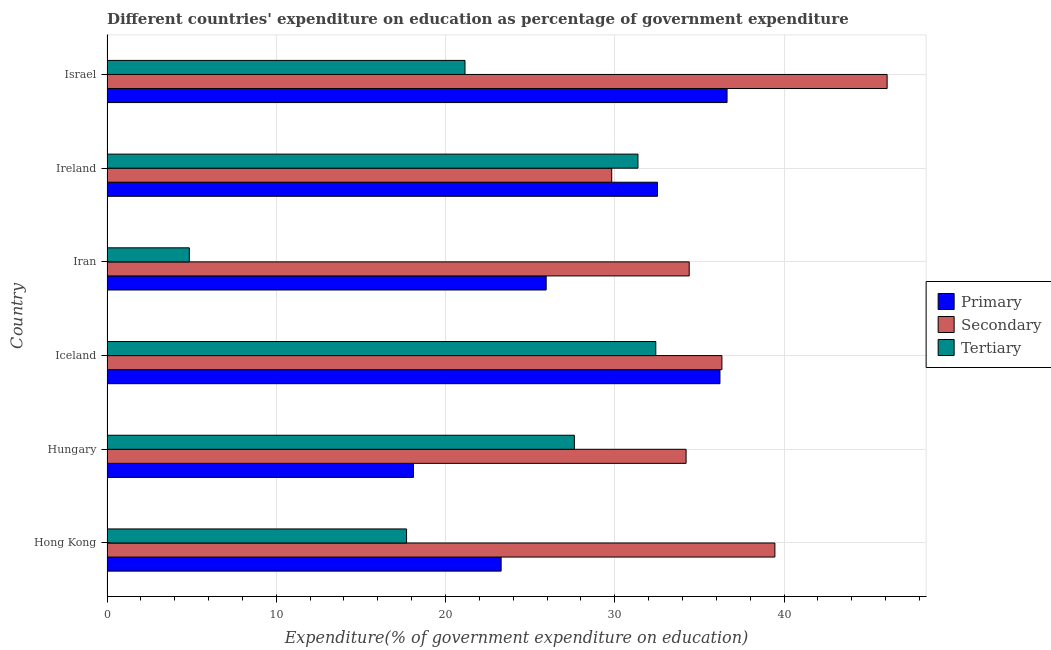How many groups of bars are there?
Your answer should be very brief. 6. How many bars are there on the 4th tick from the top?
Your answer should be compact. 3. What is the label of the 5th group of bars from the top?
Offer a very short reply. Hungary. In how many cases, is the number of bars for a given country not equal to the number of legend labels?
Give a very brief answer. 0. What is the expenditure on secondary education in Israel?
Provide a short and direct response. 46.09. Across all countries, what is the maximum expenditure on tertiary education?
Your response must be concise. 32.42. Across all countries, what is the minimum expenditure on secondary education?
Give a very brief answer. 29.82. In which country was the expenditure on primary education maximum?
Ensure brevity in your answer.  Israel. In which country was the expenditure on secondary education minimum?
Give a very brief answer. Ireland. What is the total expenditure on primary education in the graph?
Provide a short and direct response. 172.71. What is the difference between the expenditure on primary education in Iceland and that in Iran?
Ensure brevity in your answer.  10.27. What is the difference between the expenditure on secondary education in Ireland and the expenditure on primary education in Iceland?
Provide a short and direct response. -6.4. What is the average expenditure on tertiary education per country?
Your answer should be compact. 22.52. What is the difference between the expenditure on secondary education and expenditure on primary education in Israel?
Provide a short and direct response. 9.46. In how many countries, is the expenditure on tertiary education greater than 30 %?
Make the answer very short. 2. What is the ratio of the expenditure on tertiary education in Iran to that in Ireland?
Provide a short and direct response. 0.15. Is the expenditure on primary education in Hong Kong less than that in Hungary?
Your answer should be compact. No. What is the difference between the highest and the second highest expenditure on primary education?
Give a very brief answer. 0.42. What is the difference between the highest and the lowest expenditure on secondary education?
Your answer should be very brief. 16.27. What does the 2nd bar from the top in Iceland represents?
Keep it short and to the point. Secondary. What does the 3rd bar from the bottom in Hong Kong represents?
Make the answer very short. Tertiary. Are all the bars in the graph horizontal?
Offer a very short reply. Yes. What is the difference between two consecutive major ticks on the X-axis?
Your answer should be very brief. 10. Are the values on the major ticks of X-axis written in scientific E-notation?
Your answer should be compact. No. How many legend labels are there?
Offer a terse response. 3. How are the legend labels stacked?
Offer a very short reply. Vertical. What is the title of the graph?
Keep it short and to the point. Different countries' expenditure on education as percentage of government expenditure. What is the label or title of the X-axis?
Make the answer very short. Expenditure(% of government expenditure on education). What is the Expenditure(% of government expenditure on education) of Primary in Hong Kong?
Offer a very short reply. 23.29. What is the Expenditure(% of government expenditure on education) in Secondary in Hong Kong?
Your answer should be compact. 39.46. What is the Expenditure(% of government expenditure on education) in Tertiary in Hong Kong?
Your answer should be very brief. 17.7. What is the Expenditure(% of government expenditure on education) of Primary in Hungary?
Provide a short and direct response. 18.11. What is the Expenditure(% of government expenditure on education) in Secondary in Hungary?
Provide a succinct answer. 34.21. What is the Expenditure(% of government expenditure on education) in Tertiary in Hungary?
Offer a very short reply. 27.61. What is the Expenditure(% of government expenditure on education) of Primary in Iceland?
Offer a terse response. 36.21. What is the Expenditure(% of government expenditure on education) in Secondary in Iceland?
Your answer should be very brief. 36.33. What is the Expenditure(% of government expenditure on education) of Tertiary in Iceland?
Your answer should be compact. 32.42. What is the Expenditure(% of government expenditure on education) of Primary in Iran?
Your response must be concise. 25.95. What is the Expenditure(% of government expenditure on education) in Secondary in Iran?
Make the answer very short. 34.4. What is the Expenditure(% of government expenditure on education) in Tertiary in Iran?
Your response must be concise. 4.86. What is the Expenditure(% of government expenditure on education) in Primary in Ireland?
Provide a short and direct response. 32.52. What is the Expenditure(% of government expenditure on education) in Secondary in Ireland?
Offer a terse response. 29.82. What is the Expenditure(% of government expenditure on education) of Tertiary in Ireland?
Your response must be concise. 31.37. What is the Expenditure(% of government expenditure on education) of Primary in Israel?
Provide a short and direct response. 36.63. What is the Expenditure(% of government expenditure on education) in Secondary in Israel?
Offer a very short reply. 46.09. What is the Expenditure(% of government expenditure on education) in Tertiary in Israel?
Offer a terse response. 21.15. Across all countries, what is the maximum Expenditure(% of government expenditure on education) of Primary?
Provide a succinct answer. 36.63. Across all countries, what is the maximum Expenditure(% of government expenditure on education) in Secondary?
Give a very brief answer. 46.09. Across all countries, what is the maximum Expenditure(% of government expenditure on education) of Tertiary?
Ensure brevity in your answer.  32.42. Across all countries, what is the minimum Expenditure(% of government expenditure on education) of Primary?
Provide a succinct answer. 18.11. Across all countries, what is the minimum Expenditure(% of government expenditure on education) of Secondary?
Your response must be concise. 29.82. Across all countries, what is the minimum Expenditure(% of government expenditure on education) of Tertiary?
Make the answer very short. 4.86. What is the total Expenditure(% of government expenditure on education) in Primary in the graph?
Make the answer very short. 172.71. What is the total Expenditure(% of government expenditure on education) in Secondary in the graph?
Offer a terse response. 220.31. What is the total Expenditure(% of government expenditure on education) of Tertiary in the graph?
Make the answer very short. 135.12. What is the difference between the Expenditure(% of government expenditure on education) of Primary in Hong Kong and that in Hungary?
Your response must be concise. 5.18. What is the difference between the Expenditure(% of government expenditure on education) in Secondary in Hong Kong and that in Hungary?
Offer a very short reply. 5.25. What is the difference between the Expenditure(% of government expenditure on education) in Tertiary in Hong Kong and that in Hungary?
Offer a very short reply. -9.92. What is the difference between the Expenditure(% of government expenditure on education) in Primary in Hong Kong and that in Iceland?
Provide a short and direct response. -12.93. What is the difference between the Expenditure(% of government expenditure on education) of Secondary in Hong Kong and that in Iceland?
Offer a terse response. 3.13. What is the difference between the Expenditure(% of government expenditure on education) in Tertiary in Hong Kong and that in Iceland?
Provide a short and direct response. -14.73. What is the difference between the Expenditure(% of government expenditure on education) in Primary in Hong Kong and that in Iran?
Give a very brief answer. -2.66. What is the difference between the Expenditure(% of government expenditure on education) of Secondary in Hong Kong and that in Iran?
Ensure brevity in your answer.  5.06. What is the difference between the Expenditure(% of government expenditure on education) in Tertiary in Hong Kong and that in Iran?
Give a very brief answer. 12.84. What is the difference between the Expenditure(% of government expenditure on education) of Primary in Hong Kong and that in Ireland?
Offer a terse response. -9.24. What is the difference between the Expenditure(% of government expenditure on education) of Secondary in Hong Kong and that in Ireland?
Ensure brevity in your answer.  9.64. What is the difference between the Expenditure(% of government expenditure on education) in Tertiary in Hong Kong and that in Ireland?
Make the answer very short. -13.67. What is the difference between the Expenditure(% of government expenditure on education) of Primary in Hong Kong and that in Israel?
Your response must be concise. -13.35. What is the difference between the Expenditure(% of government expenditure on education) in Secondary in Hong Kong and that in Israel?
Your response must be concise. -6.63. What is the difference between the Expenditure(% of government expenditure on education) in Tertiary in Hong Kong and that in Israel?
Offer a very short reply. -3.45. What is the difference between the Expenditure(% of government expenditure on education) in Primary in Hungary and that in Iceland?
Provide a short and direct response. -18.11. What is the difference between the Expenditure(% of government expenditure on education) of Secondary in Hungary and that in Iceland?
Keep it short and to the point. -2.12. What is the difference between the Expenditure(% of government expenditure on education) in Tertiary in Hungary and that in Iceland?
Make the answer very short. -4.81. What is the difference between the Expenditure(% of government expenditure on education) of Primary in Hungary and that in Iran?
Ensure brevity in your answer.  -7.84. What is the difference between the Expenditure(% of government expenditure on education) in Secondary in Hungary and that in Iran?
Your answer should be very brief. -0.18. What is the difference between the Expenditure(% of government expenditure on education) of Tertiary in Hungary and that in Iran?
Provide a short and direct response. 22.75. What is the difference between the Expenditure(% of government expenditure on education) in Primary in Hungary and that in Ireland?
Your answer should be compact. -14.42. What is the difference between the Expenditure(% of government expenditure on education) of Secondary in Hungary and that in Ireland?
Provide a short and direct response. 4.4. What is the difference between the Expenditure(% of government expenditure on education) in Tertiary in Hungary and that in Ireland?
Ensure brevity in your answer.  -3.76. What is the difference between the Expenditure(% of government expenditure on education) in Primary in Hungary and that in Israel?
Ensure brevity in your answer.  -18.53. What is the difference between the Expenditure(% of government expenditure on education) of Secondary in Hungary and that in Israel?
Provide a succinct answer. -11.88. What is the difference between the Expenditure(% of government expenditure on education) of Tertiary in Hungary and that in Israel?
Your response must be concise. 6.46. What is the difference between the Expenditure(% of government expenditure on education) in Primary in Iceland and that in Iran?
Provide a succinct answer. 10.27. What is the difference between the Expenditure(% of government expenditure on education) of Secondary in Iceland and that in Iran?
Offer a terse response. 1.93. What is the difference between the Expenditure(% of government expenditure on education) of Tertiary in Iceland and that in Iran?
Your answer should be compact. 27.56. What is the difference between the Expenditure(% of government expenditure on education) in Primary in Iceland and that in Ireland?
Ensure brevity in your answer.  3.69. What is the difference between the Expenditure(% of government expenditure on education) in Secondary in Iceland and that in Ireland?
Give a very brief answer. 6.51. What is the difference between the Expenditure(% of government expenditure on education) in Tertiary in Iceland and that in Ireland?
Your answer should be very brief. 1.05. What is the difference between the Expenditure(% of government expenditure on education) of Primary in Iceland and that in Israel?
Keep it short and to the point. -0.42. What is the difference between the Expenditure(% of government expenditure on education) in Secondary in Iceland and that in Israel?
Your answer should be very brief. -9.76. What is the difference between the Expenditure(% of government expenditure on education) of Tertiary in Iceland and that in Israel?
Your response must be concise. 11.27. What is the difference between the Expenditure(% of government expenditure on education) of Primary in Iran and that in Ireland?
Provide a short and direct response. -6.58. What is the difference between the Expenditure(% of government expenditure on education) in Secondary in Iran and that in Ireland?
Ensure brevity in your answer.  4.58. What is the difference between the Expenditure(% of government expenditure on education) in Tertiary in Iran and that in Ireland?
Give a very brief answer. -26.51. What is the difference between the Expenditure(% of government expenditure on education) of Primary in Iran and that in Israel?
Your response must be concise. -10.69. What is the difference between the Expenditure(% of government expenditure on education) in Secondary in Iran and that in Israel?
Ensure brevity in your answer.  -11.69. What is the difference between the Expenditure(% of government expenditure on education) in Tertiary in Iran and that in Israel?
Your answer should be very brief. -16.29. What is the difference between the Expenditure(% of government expenditure on education) of Primary in Ireland and that in Israel?
Keep it short and to the point. -4.11. What is the difference between the Expenditure(% of government expenditure on education) of Secondary in Ireland and that in Israel?
Offer a very short reply. -16.27. What is the difference between the Expenditure(% of government expenditure on education) of Tertiary in Ireland and that in Israel?
Your answer should be compact. 10.22. What is the difference between the Expenditure(% of government expenditure on education) of Primary in Hong Kong and the Expenditure(% of government expenditure on education) of Secondary in Hungary?
Give a very brief answer. -10.93. What is the difference between the Expenditure(% of government expenditure on education) of Primary in Hong Kong and the Expenditure(% of government expenditure on education) of Tertiary in Hungary?
Provide a short and direct response. -4.33. What is the difference between the Expenditure(% of government expenditure on education) in Secondary in Hong Kong and the Expenditure(% of government expenditure on education) in Tertiary in Hungary?
Your answer should be very brief. 11.85. What is the difference between the Expenditure(% of government expenditure on education) in Primary in Hong Kong and the Expenditure(% of government expenditure on education) in Secondary in Iceland?
Ensure brevity in your answer.  -13.04. What is the difference between the Expenditure(% of government expenditure on education) of Primary in Hong Kong and the Expenditure(% of government expenditure on education) of Tertiary in Iceland?
Your answer should be compact. -9.14. What is the difference between the Expenditure(% of government expenditure on education) in Secondary in Hong Kong and the Expenditure(% of government expenditure on education) in Tertiary in Iceland?
Give a very brief answer. 7.04. What is the difference between the Expenditure(% of government expenditure on education) in Primary in Hong Kong and the Expenditure(% of government expenditure on education) in Secondary in Iran?
Your response must be concise. -11.11. What is the difference between the Expenditure(% of government expenditure on education) in Primary in Hong Kong and the Expenditure(% of government expenditure on education) in Tertiary in Iran?
Your response must be concise. 18.42. What is the difference between the Expenditure(% of government expenditure on education) in Secondary in Hong Kong and the Expenditure(% of government expenditure on education) in Tertiary in Iran?
Keep it short and to the point. 34.6. What is the difference between the Expenditure(% of government expenditure on education) in Primary in Hong Kong and the Expenditure(% of government expenditure on education) in Secondary in Ireland?
Keep it short and to the point. -6.53. What is the difference between the Expenditure(% of government expenditure on education) of Primary in Hong Kong and the Expenditure(% of government expenditure on education) of Tertiary in Ireland?
Ensure brevity in your answer.  -8.08. What is the difference between the Expenditure(% of government expenditure on education) in Secondary in Hong Kong and the Expenditure(% of government expenditure on education) in Tertiary in Ireland?
Offer a terse response. 8.09. What is the difference between the Expenditure(% of government expenditure on education) in Primary in Hong Kong and the Expenditure(% of government expenditure on education) in Secondary in Israel?
Make the answer very short. -22.81. What is the difference between the Expenditure(% of government expenditure on education) of Primary in Hong Kong and the Expenditure(% of government expenditure on education) of Tertiary in Israel?
Your answer should be compact. 2.13. What is the difference between the Expenditure(% of government expenditure on education) of Secondary in Hong Kong and the Expenditure(% of government expenditure on education) of Tertiary in Israel?
Provide a short and direct response. 18.31. What is the difference between the Expenditure(% of government expenditure on education) in Primary in Hungary and the Expenditure(% of government expenditure on education) in Secondary in Iceland?
Your answer should be compact. -18.22. What is the difference between the Expenditure(% of government expenditure on education) in Primary in Hungary and the Expenditure(% of government expenditure on education) in Tertiary in Iceland?
Offer a terse response. -14.32. What is the difference between the Expenditure(% of government expenditure on education) in Secondary in Hungary and the Expenditure(% of government expenditure on education) in Tertiary in Iceland?
Provide a succinct answer. 1.79. What is the difference between the Expenditure(% of government expenditure on education) in Primary in Hungary and the Expenditure(% of government expenditure on education) in Secondary in Iran?
Your answer should be compact. -16.29. What is the difference between the Expenditure(% of government expenditure on education) of Primary in Hungary and the Expenditure(% of government expenditure on education) of Tertiary in Iran?
Keep it short and to the point. 13.24. What is the difference between the Expenditure(% of government expenditure on education) in Secondary in Hungary and the Expenditure(% of government expenditure on education) in Tertiary in Iran?
Your answer should be compact. 29.35. What is the difference between the Expenditure(% of government expenditure on education) in Primary in Hungary and the Expenditure(% of government expenditure on education) in Secondary in Ireland?
Your answer should be compact. -11.71. What is the difference between the Expenditure(% of government expenditure on education) of Primary in Hungary and the Expenditure(% of government expenditure on education) of Tertiary in Ireland?
Ensure brevity in your answer.  -13.26. What is the difference between the Expenditure(% of government expenditure on education) of Secondary in Hungary and the Expenditure(% of government expenditure on education) of Tertiary in Ireland?
Ensure brevity in your answer.  2.84. What is the difference between the Expenditure(% of government expenditure on education) in Primary in Hungary and the Expenditure(% of government expenditure on education) in Secondary in Israel?
Your answer should be compact. -27.98. What is the difference between the Expenditure(% of government expenditure on education) of Primary in Hungary and the Expenditure(% of government expenditure on education) of Tertiary in Israel?
Your response must be concise. -3.04. What is the difference between the Expenditure(% of government expenditure on education) in Secondary in Hungary and the Expenditure(% of government expenditure on education) in Tertiary in Israel?
Your answer should be compact. 13.06. What is the difference between the Expenditure(% of government expenditure on education) of Primary in Iceland and the Expenditure(% of government expenditure on education) of Secondary in Iran?
Ensure brevity in your answer.  1.82. What is the difference between the Expenditure(% of government expenditure on education) in Primary in Iceland and the Expenditure(% of government expenditure on education) in Tertiary in Iran?
Your answer should be compact. 31.35. What is the difference between the Expenditure(% of government expenditure on education) in Secondary in Iceland and the Expenditure(% of government expenditure on education) in Tertiary in Iran?
Your answer should be very brief. 31.47. What is the difference between the Expenditure(% of government expenditure on education) of Primary in Iceland and the Expenditure(% of government expenditure on education) of Secondary in Ireland?
Offer a very short reply. 6.4. What is the difference between the Expenditure(% of government expenditure on education) in Primary in Iceland and the Expenditure(% of government expenditure on education) in Tertiary in Ireland?
Your answer should be very brief. 4.84. What is the difference between the Expenditure(% of government expenditure on education) in Secondary in Iceland and the Expenditure(% of government expenditure on education) in Tertiary in Ireland?
Ensure brevity in your answer.  4.96. What is the difference between the Expenditure(% of government expenditure on education) of Primary in Iceland and the Expenditure(% of government expenditure on education) of Secondary in Israel?
Offer a terse response. -9.88. What is the difference between the Expenditure(% of government expenditure on education) in Primary in Iceland and the Expenditure(% of government expenditure on education) in Tertiary in Israel?
Ensure brevity in your answer.  15.06. What is the difference between the Expenditure(% of government expenditure on education) in Secondary in Iceland and the Expenditure(% of government expenditure on education) in Tertiary in Israel?
Offer a terse response. 15.18. What is the difference between the Expenditure(% of government expenditure on education) in Primary in Iran and the Expenditure(% of government expenditure on education) in Secondary in Ireland?
Your response must be concise. -3.87. What is the difference between the Expenditure(% of government expenditure on education) of Primary in Iran and the Expenditure(% of government expenditure on education) of Tertiary in Ireland?
Make the answer very short. -5.42. What is the difference between the Expenditure(% of government expenditure on education) in Secondary in Iran and the Expenditure(% of government expenditure on education) in Tertiary in Ireland?
Make the answer very short. 3.03. What is the difference between the Expenditure(% of government expenditure on education) of Primary in Iran and the Expenditure(% of government expenditure on education) of Secondary in Israel?
Offer a terse response. -20.14. What is the difference between the Expenditure(% of government expenditure on education) in Primary in Iran and the Expenditure(% of government expenditure on education) in Tertiary in Israel?
Keep it short and to the point. 4.8. What is the difference between the Expenditure(% of government expenditure on education) in Secondary in Iran and the Expenditure(% of government expenditure on education) in Tertiary in Israel?
Make the answer very short. 13.25. What is the difference between the Expenditure(% of government expenditure on education) in Primary in Ireland and the Expenditure(% of government expenditure on education) in Secondary in Israel?
Keep it short and to the point. -13.57. What is the difference between the Expenditure(% of government expenditure on education) in Primary in Ireland and the Expenditure(% of government expenditure on education) in Tertiary in Israel?
Ensure brevity in your answer.  11.37. What is the difference between the Expenditure(% of government expenditure on education) of Secondary in Ireland and the Expenditure(% of government expenditure on education) of Tertiary in Israel?
Keep it short and to the point. 8.67. What is the average Expenditure(% of government expenditure on education) in Primary per country?
Make the answer very short. 28.78. What is the average Expenditure(% of government expenditure on education) of Secondary per country?
Make the answer very short. 36.72. What is the average Expenditure(% of government expenditure on education) of Tertiary per country?
Provide a succinct answer. 22.52. What is the difference between the Expenditure(% of government expenditure on education) in Primary and Expenditure(% of government expenditure on education) in Secondary in Hong Kong?
Offer a very short reply. -16.18. What is the difference between the Expenditure(% of government expenditure on education) in Primary and Expenditure(% of government expenditure on education) in Tertiary in Hong Kong?
Keep it short and to the point. 5.59. What is the difference between the Expenditure(% of government expenditure on education) of Secondary and Expenditure(% of government expenditure on education) of Tertiary in Hong Kong?
Provide a succinct answer. 21.76. What is the difference between the Expenditure(% of government expenditure on education) of Primary and Expenditure(% of government expenditure on education) of Secondary in Hungary?
Your answer should be compact. -16.11. What is the difference between the Expenditure(% of government expenditure on education) in Primary and Expenditure(% of government expenditure on education) in Tertiary in Hungary?
Offer a terse response. -9.51. What is the difference between the Expenditure(% of government expenditure on education) in Secondary and Expenditure(% of government expenditure on education) in Tertiary in Hungary?
Give a very brief answer. 6.6. What is the difference between the Expenditure(% of government expenditure on education) in Primary and Expenditure(% of government expenditure on education) in Secondary in Iceland?
Offer a very short reply. -0.12. What is the difference between the Expenditure(% of government expenditure on education) in Primary and Expenditure(% of government expenditure on education) in Tertiary in Iceland?
Keep it short and to the point. 3.79. What is the difference between the Expenditure(% of government expenditure on education) in Secondary and Expenditure(% of government expenditure on education) in Tertiary in Iceland?
Your response must be concise. 3.91. What is the difference between the Expenditure(% of government expenditure on education) of Primary and Expenditure(% of government expenditure on education) of Secondary in Iran?
Keep it short and to the point. -8.45. What is the difference between the Expenditure(% of government expenditure on education) of Primary and Expenditure(% of government expenditure on education) of Tertiary in Iran?
Offer a terse response. 21.08. What is the difference between the Expenditure(% of government expenditure on education) of Secondary and Expenditure(% of government expenditure on education) of Tertiary in Iran?
Offer a terse response. 29.53. What is the difference between the Expenditure(% of government expenditure on education) in Primary and Expenditure(% of government expenditure on education) in Secondary in Ireland?
Your answer should be compact. 2.7. What is the difference between the Expenditure(% of government expenditure on education) in Primary and Expenditure(% of government expenditure on education) in Tertiary in Ireland?
Provide a short and direct response. 1.15. What is the difference between the Expenditure(% of government expenditure on education) of Secondary and Expenditure(% of government expenditure on education) of Tertiary in Ireland?
Your response must be concise. -1.55. What is the difference between the Expenditure(% of government expenditure on education) of Primary and Expenditure(% of government expenditure on education) of Secondary in Israel?
Offer a very short reply. -9.46. What is the difference between the Expenditure(% of government expenditure on education) in Primary and Expenditure(% of government expenditure on education) in Tertiary in Israel?
Provide a short and direct response. 15.48. What is the difference between the Expenditure(% of government expenditure on education) of Secondary and Expenditure(% of government expenditure on education) of Tertiary in Israel?
Your response must be concise. 24.94. What is the ratio of the Expenditure(% of government expenditure on education) in Primary in Hong Kong to that in Hungary?
Keep it short and to the point. 1.29. What is the ratio of the Expenditure(% of government expenditure on education) of Secondary in Hong Kong to that in Hungary?
Your answer should be compact. 1.15. What is the ratio of the Expenditure(% of government expenditure on education) of Tertiary in Hong Kong to that in Hungary?
Your answer should be compact. 0.64. What is the ratio of the Expenditure(% of government expenditure on education) in Primary in Hong Kong to that in Iceland?
Make the answer very short. 0.64. What is the ratio of the Expenditure(% of government expenditure on education) in Secondary in Hong Kong to that in Iceland?
Provide a short and direct response. 1.09. What is the ratio of the Expenditure(% of government expenditure on education) in Tertiary in Hong Kong to that in Iceland?
Your answer should be compact. 0.55. What is the ratio of the Expenditure(% of government expenditure on education) of Primary in Hong Kong to that in Iran?
Your answer should be very brief. 0.9. What is the ratio of the Expenditure(% of government expenditure on education) of Secondary in Hong Kong to that in Iran?
Offer a very short reply. 1.15. What is the ratio of the Expenditure(% of government expenditure on education) of Tertiary in Hong Kong to that in Iran?
Your answer should be very brief. 3.64. What is the ratio of the Expenditure(% of government expenditure on education) in Primary in Hong Kong to that in Ireland?
Offer a very short reply. 0.72. What is the ratio of the Expenditure(% of government expenditure on education) of Secondary in Hong Kong to that in Ireland?
Your answer should be compact. 1.32. What is the ratio of the Expenditure(% of government expenditure on education) in Tertiary in Hong Kong to that in Ireland?
Your answer should be very brief. 0.56. What is the ratio of the Expenditure(% of government expenditure on education) of Primary in Hong Kong to that in Israel?
Offer a terse response. 0.64. What is the ratio of the Expenditure(% of government expenditure on education) of Secondary in Hong Kong to that in Israel?
Provide a short and direct response. 0.86. What is the ratio of the Expenditure(% of government expenditure on education) in Tertiary in Hong Kong to that in Israel?
Offer a very short reply. 0.84. What is the ratio of the Expenditure(% of government expenditure on education) of Primary in Hungary to that in Iceland?
Your answer should be very brief. 0.5. What is the ratio of the Expenditure(% of government expenditure on education) of Secondary in Hungary to that in Iceland?
Provide a succinct answer. 0.94. What is the ratio of the Expenditure(% of government expenditure on education) of Tertiary in Hungary to that in Iceland?
Offer a very short reply. 0.85. What is the ratio of the Expenditure(% of government expenditure on education) of Primary in Hungary to that in Iran?
Offer a terse response. 0.7. What is the ratio of the Expenditure(% of government expenditure on education) of Tertiary in Hungary to that in Iran?
Provide a short and direct response. 5.68. What is the ratio of the Expenditure(% of government expenditure on education) in Primary in Hungary to that in Ireland?
Ensure brevity in your answer.  0.56. What is the ratio of the Expenditure(% of government expenditure on education) of Secondary in Hungary to that in Ireland?
Offer a very short reply. 1.15. What is the ratio of the Expenditure(% of government expenditure on education) in Tertiary in Hungary to that in Ireland?
Give a very brief answer. 0.88. What is the ratio of the Expenditure(% of government expenditure on education) of Primary in Hungary to that in Israel?
Give a very brief answer. 0.49. What is the ratio of the Expenditure(% of government expenditure on education) in Secondary in Hungary to that in Israel?
Your answer should be very brief. 0.74. What is the ratio of the Expenditure(% of government expenditure on education) in Tertiary in Hungary to that in Israel?
Keep it short and to the point. 1.31. What is the ratio of the Expenditure(% of government expenditure on education) of Primary in Iceland to that in Iran?
Your answer should be compact. 1.4. What is the ratio of the Expenditure(% of government expenditure on education) in Secondary in Iceland to that in Iran?
Keep it short and to the point. 1.06. What is the ratio of the Expenditure(% of government expenditure on education) of Tertiary in Iceland to that in Iran?
Your response must be concise. 6.67. What is the ratio of the Expenditure(% of government expenditure on education) of Primary in Iceland to that in Ireland?
Offer a very short reply. 1.11. What is the ratio of the Expenditure(% of government expenditure on education) of Secondary in Iceland to that in Ireland?
Provide a short and direct response. 1.22. What is the ratio of the Expenditure(% of government expenditure on education) of Tertiary in Iceland to that in Ireland?
Keep it short and to the point. 1.03. What is the ratio of the Expenditure(% of government expenditure on education) in Secondary in Iceland to that in Israel?
Provide a short and direct response. 0.79. What is the ratio of the Expenditure(% of government expenditure on education) of Tertiary in Iceland to that in Israel?
Offer a terse response. 1.53. What is the ratio of the Expenditure(% of government expenditure on education) of Primary in Iran to that in Ireland?
Your answer should be very brief. 0.8. What is the ratio of the Expenditure(% of government expenditure on education) in Secondary in Iran to that in Ireland?
Keep it short and to the point. 1.15. What is the ratio of the Expenditure(% of government expenditure on education) in Tertiary in Iran to that in Ireland?
Give a very brief answer. 0.15. What is the ratio of the Expenditure(% of government expenditure on education) of Primary in Iran to that in Israel?
Ensure brevity in your answer.  0.71. What is the ratio of the Expenditure(% of government expenditure on education) of Secondary in Iran to that in Israel?
Give a very brief answer. 0.75. What is the ratio of the Expenditure(% of government expenditure on education) in Tertiary in Iran to that in Israel?
Give a very brief answer. 0.23. What is the ratio of the Expenditure(% of government expenditure on education) of Primary in Ireland to that in Israel?
Make the answer very short. 0.89. What is the ratio of the Expenditure(% of government expenditure on education) in Secondary in Ireland to that in Israel?
Give a very brief answer. 0.65. What is the ratio of the Expenditure(% of government expenditure on education) of Tertiary in Ireland to that in Israel?
Your response must be concise. 1.48. What is the difference between the highest and the second highest Expenditure(% of government expenditure on education) of Primary?
Provide a succinct answer. 0.42. What is the difference between the highest and the second highest Expenditure(% of government expenditure on education) in Secondary?
Provide a short and direct response. 6.63. What is the difference between the highest and the second highest Expenditure(% of government expenditure on education) in Tertiary?
Your answer should be compact. 1.05. What is the difference between the highest and the lowest Expenditure(% of government expenditure on education) in Primary?
Make the answer very short. 18.53. What is the difference between the highest and the lowest Expenditure(% of government expenditure on education) in Secondary?
Offer a terse response. 16.27. What is the difference between the highest and the lowest Expenditure(% of government expenditure on education) of Tertiary?
Provide a short and direct response. 27.56. 